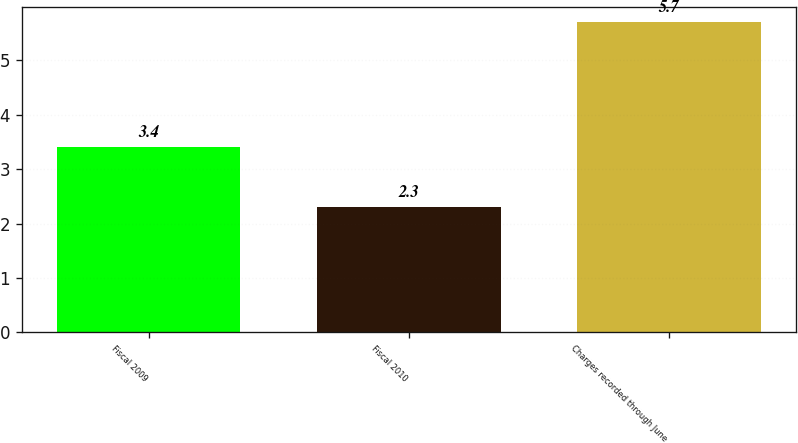Convert chart. <chart><loc_0><loc_0><loc_500><loc_500><bar_chart><fcel>Fiscal 2009<fcel>Fiscal 2010<fcel>Charges recorded through June<nl><fcel>3.4<fcel>2.3<fcel>5.7<nl></chart> 